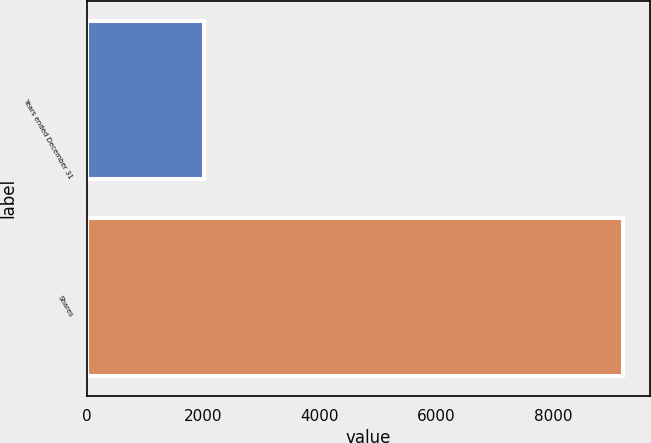Convert chart to OTSL. <chart><loc_0><loc_0><loc_500><loc_500><bar_chart><fcel>Years ended December 31<fcel>Shares<nl><fcel>2016<fcel>9211<nl></chart> 